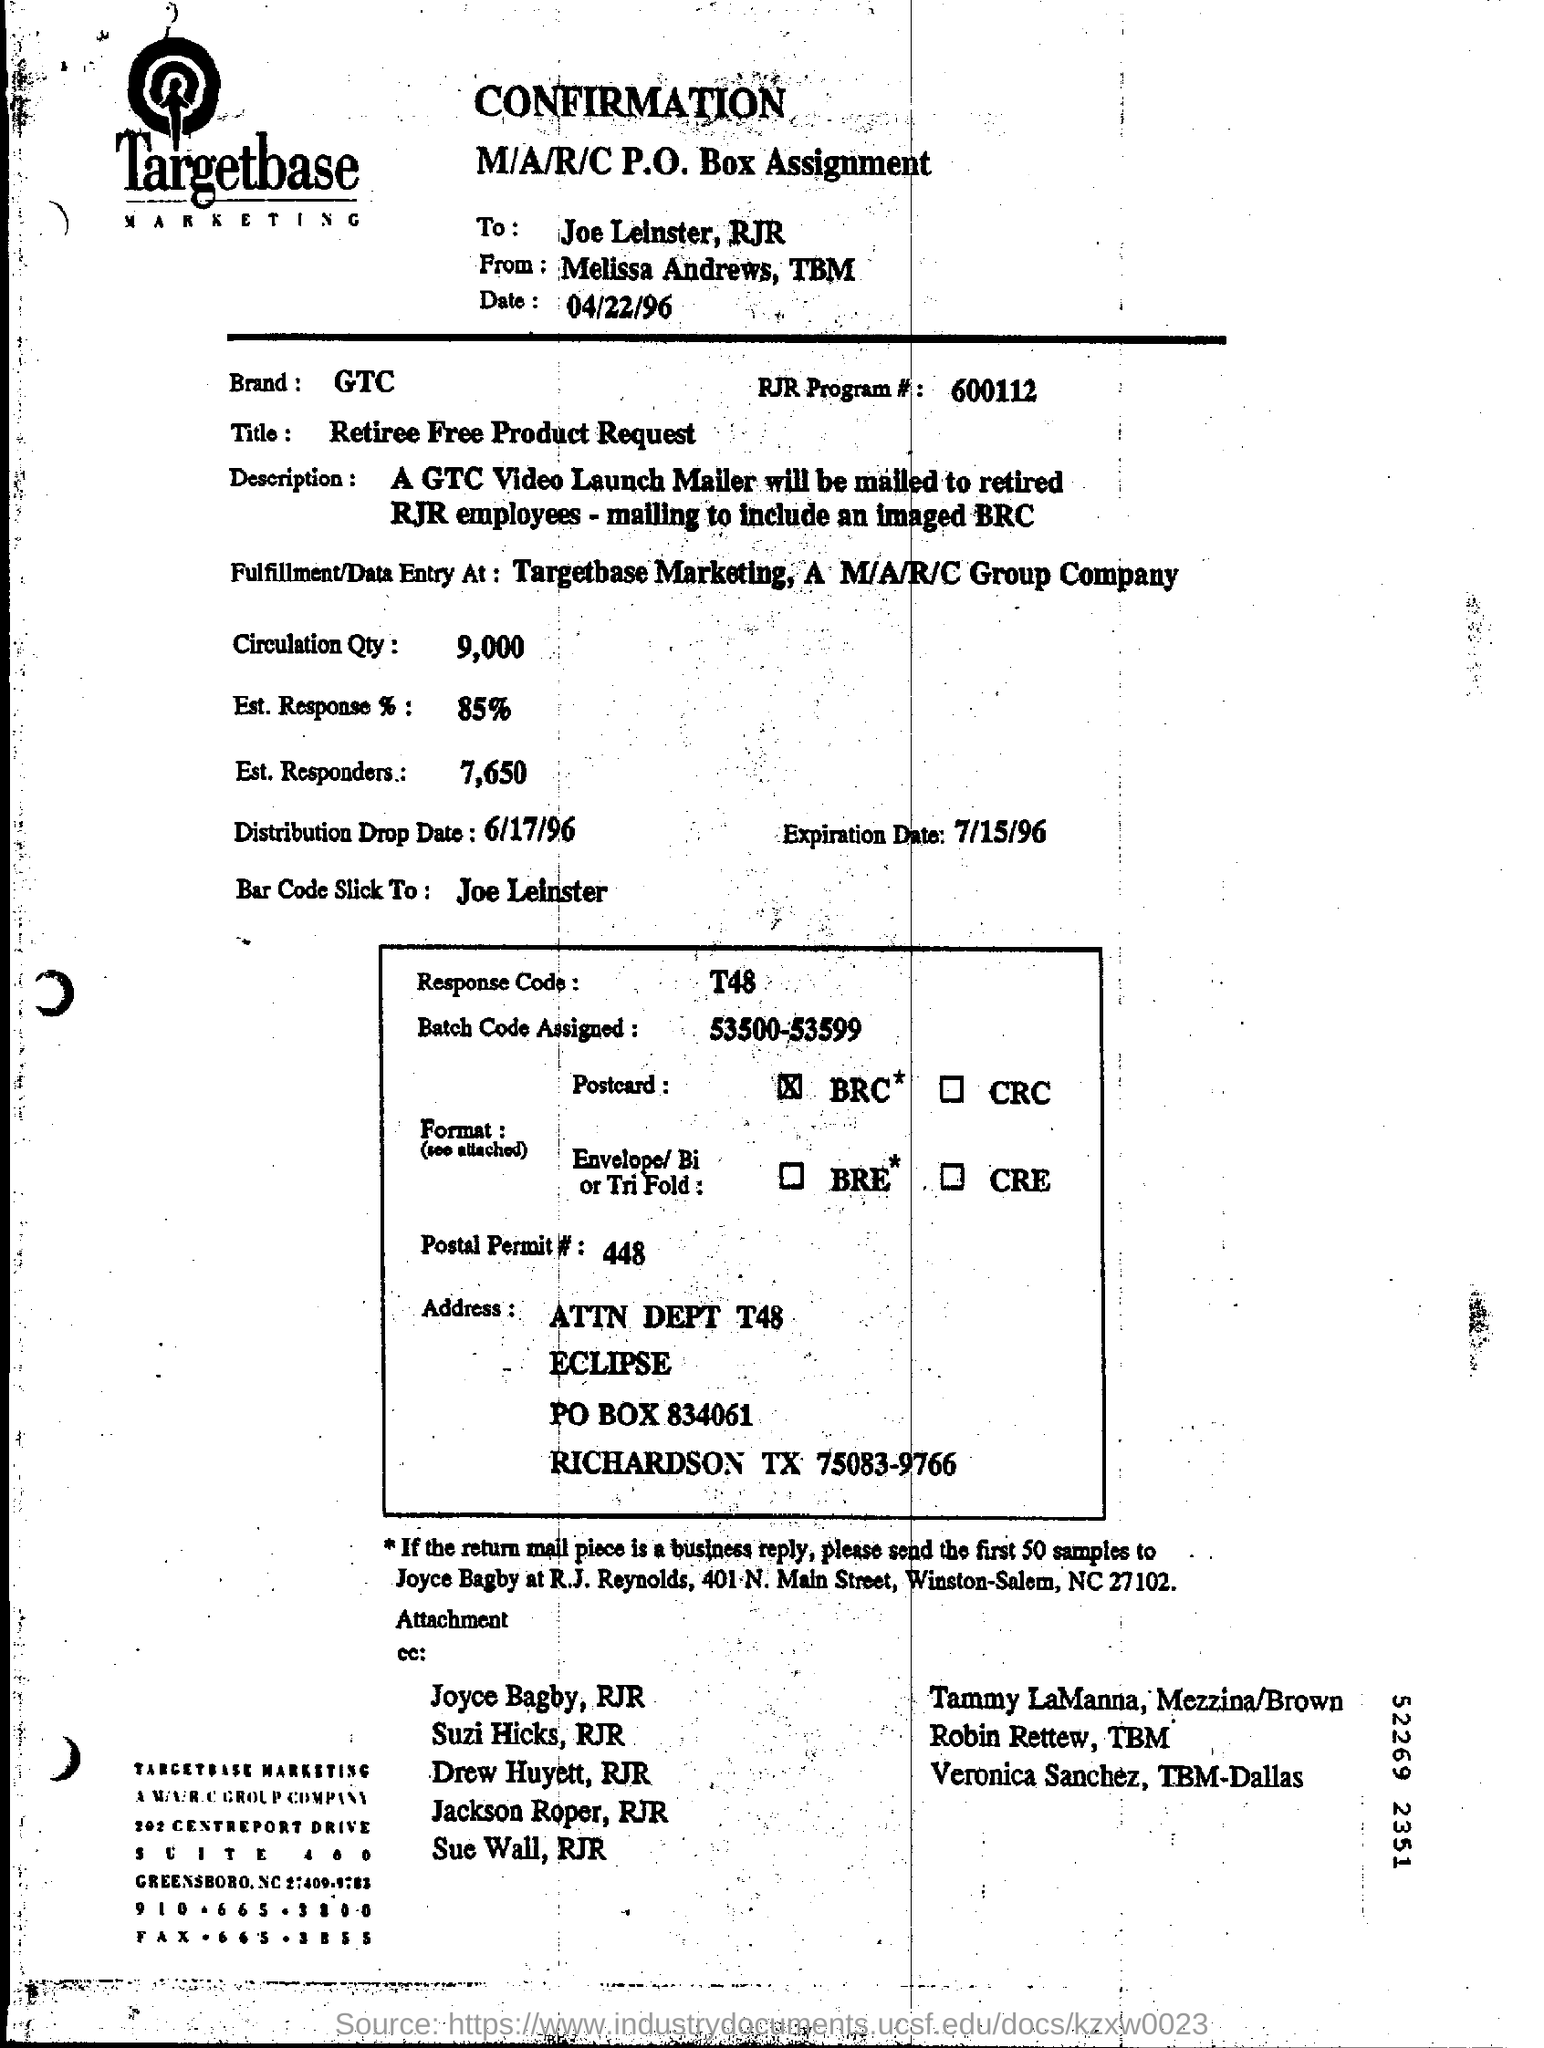Who is this from?
Make the answer very short. Melissa andrews, tbm. Who is it addressed to?
Offer a terse response. Joe leinster. What is the Date?
Offer a very short reply. 04/22/96. What is the Brand?
Provide a short and direct response. Gtc. What is the Title?
Your answer should be compact. Retiree Free Product Request. What is the RJR Program #?
Offer a terse response. 600112. What is the Circulation Qty?
Offer a very short reply. 9,000. What is the Est. Response %?
Your answer should be compact. 85%. What is the Est. Responders?
Keep it short and to the point. 7,650. What is the Response code?
Offer a very short reply. T48. What is the Postal Permit #?
Your answer should be very brief. 448. 